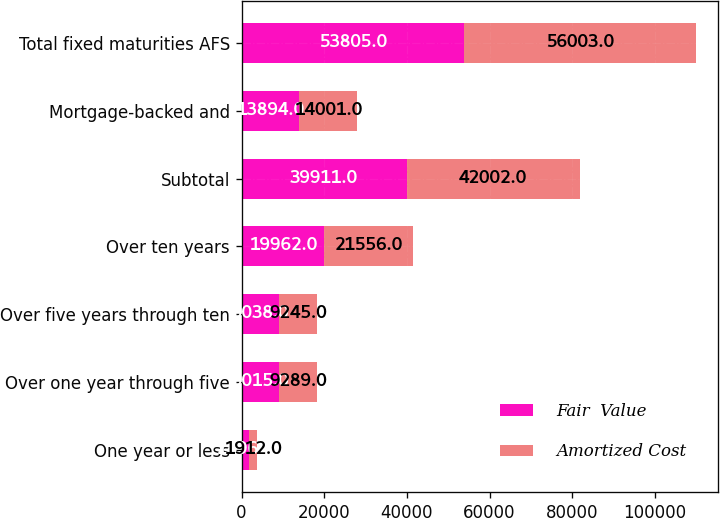Convert chart to OTSL. <chart><loc_0><loc_0><loc_500><loc_500><stacked_bar_chart><ecel><fcel>One year or less<fcel>Over one year through five<fcel>Over five years through ten<fcel>Over ten years<fcel>Subtotal<fcel>Mortgage-backed and<fcel>Total fixed maturities AFS<nl><fcel>Fair  Value<fcel>1896<fcel>9015<fcel>9038<fcel>19962<fcel>39911<fcel>13894<fcel>53805<nl><fcel>Amortized Cost<fcel>1912<fcel>9289<fcel>9245<fcel>21556<fcel>42002<fcel>14001<fcel>56003<nl></chart> 